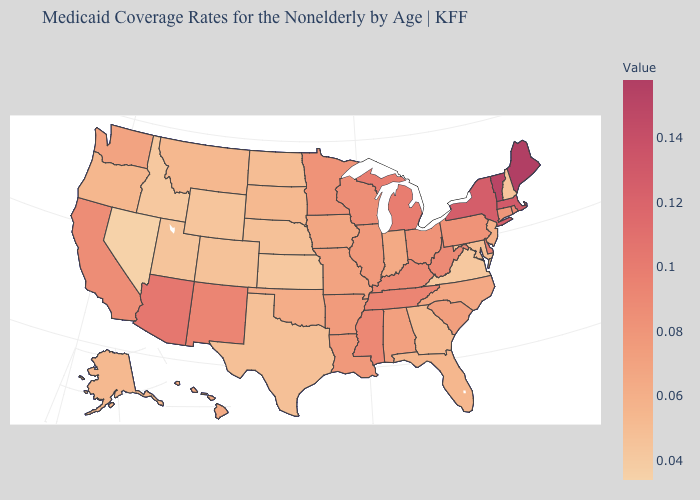Which states have the lowest value in the USA?
Write a very short answer. Nevada. Does Nevada have the lowest value in the USA?
Quick response, please. Yes. Does the map have missing data?
Be succinct. No. Does Kentucky have the lowest value in the USA?
Give a very brief answer. No. Among the states that border Georgia , which have the highest value?
Answer briefly. Tennessee. Does Michigan have a higher value than Massachusetts?
Write a very short answer. No. 